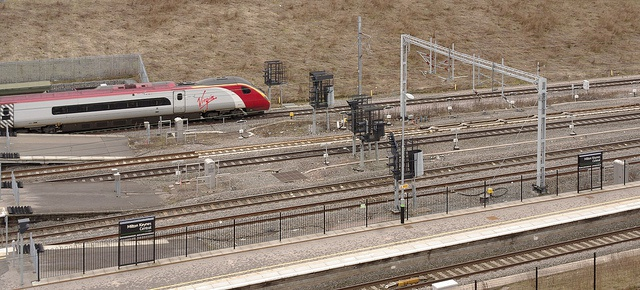Describe the objects in this image and their specific colors. I can see a train in gray, black, darkgray, and lightgray tones in this image. 